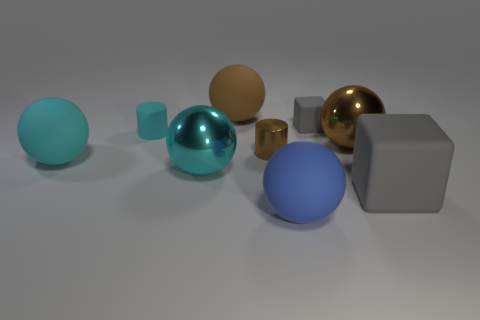Subtract all blue spheres. How many spheres are left? 4 Subtract 1 balls. How many balls are left? 4 Subtract all large cyan metallic spheres. How many spheres are left? 4 Subtract all purple spheres. Subtract all yellow cylinders. How many spheres are left? 5 Add 1 blue spheres. How many objects exist? 10 Subtract all cylinders. How many objects are left? 7 Subtract 1 blue spheres. How many objects are left? 8 Subtract all large things. Subtract all small cyan rubber blocks. How many objects are left? 3 Add 3 brown shiny spheres. How many brown shiny spheres are left? 4 Add 5 large purple metallic balls. How many large purple metallic balls exist? 5 